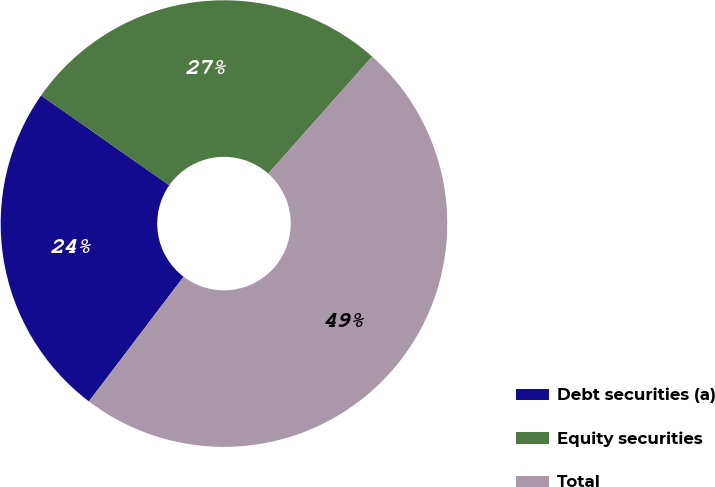Convert chart. <chart><loc_0><loc_0><loc_500><loc_500><pie_chart><fcel>Debt securities (a)<fcel>Equity securities<fcel>Total<nl><fcel>24.39%<fcel>26.83%<fcel>48.78%<nl></chart> 